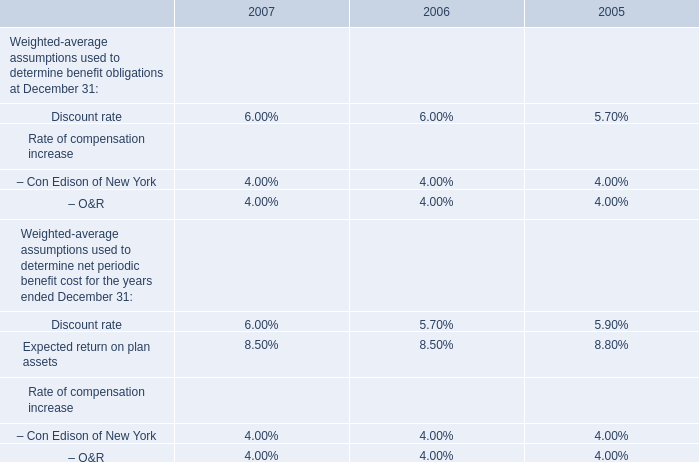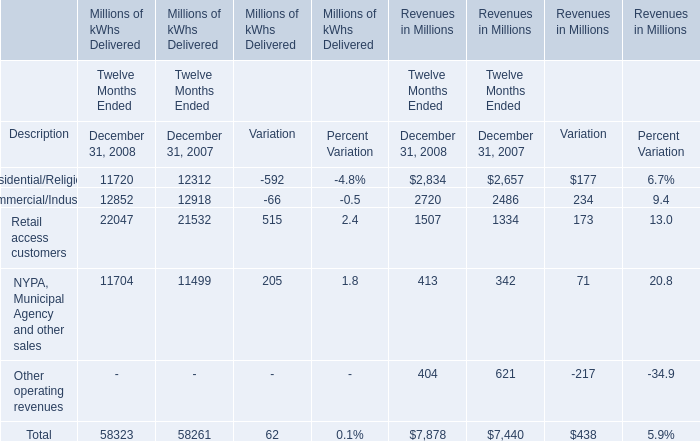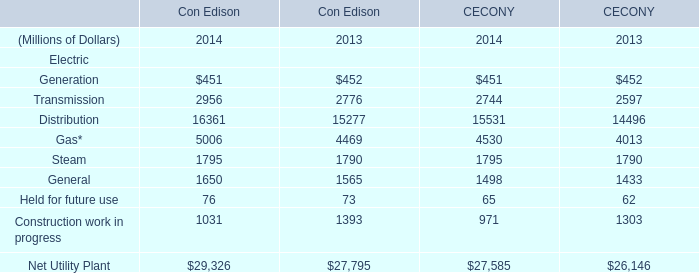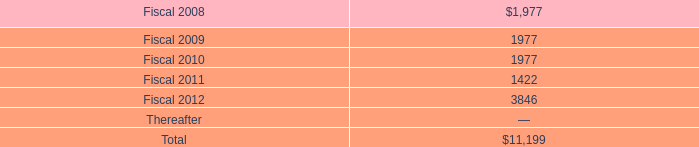In the year with the greatest proportion of Retail access customers in delivered, what is the proportion of Retail access customers in delivered to the total? 
Computations: (22047 / 58323)
Answer: 0.37802. 